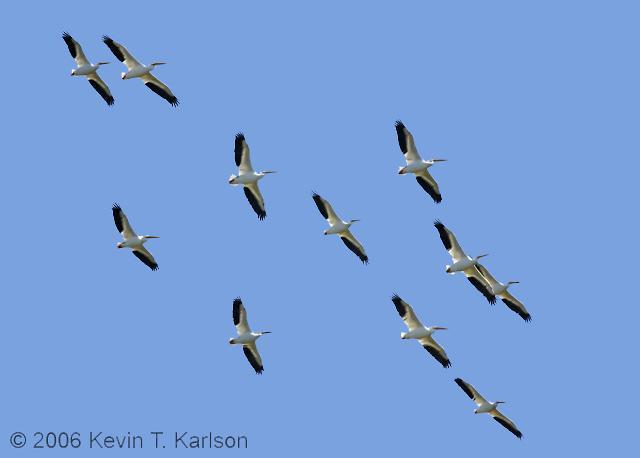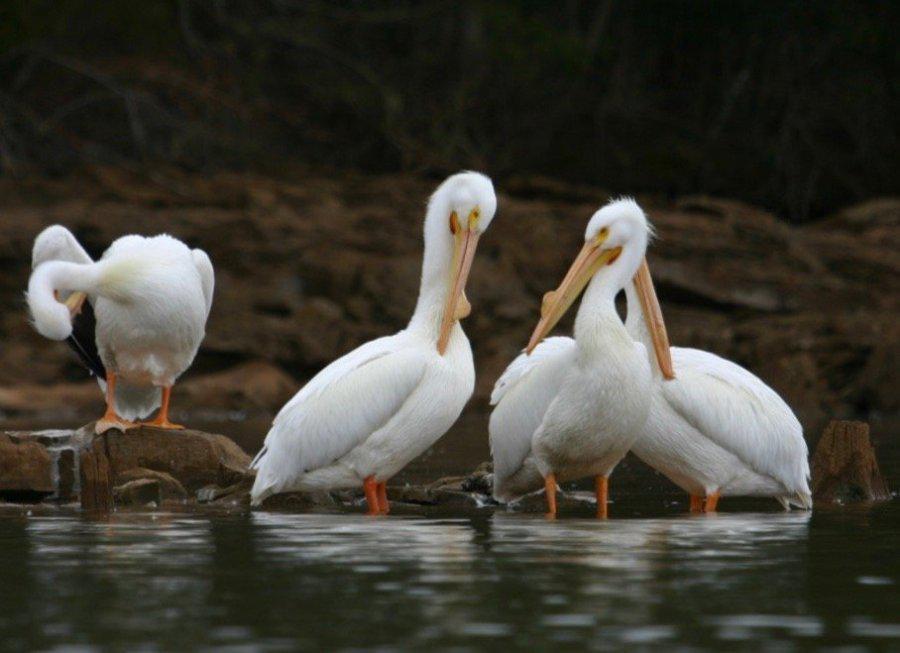The first image is the image on the left, the second image is the image on the right. For the images shown, is this caption "Some of the birds are standing in the water." true? Answer yes or no. Yes. The first image is the image on the left, the second image is the image on the right. Examine the images to the left and right. Is the description "Multiple birds are in flight in one image." accurate? Answer yes or no. Yes. 